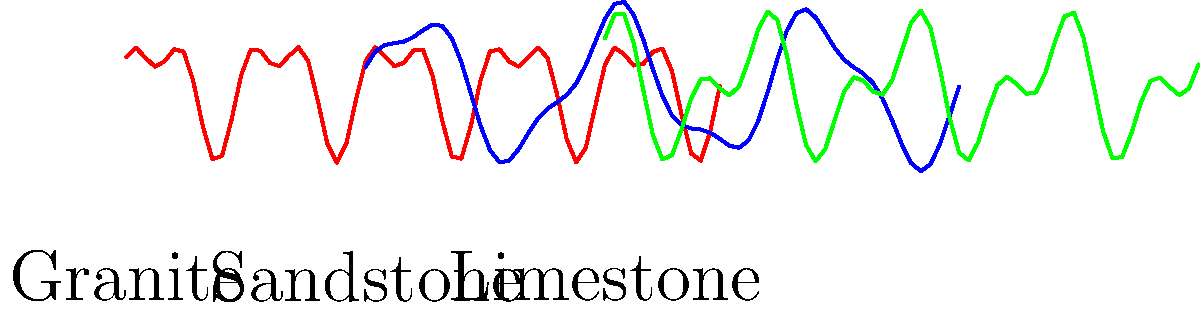Analyze the fractal patterns depicted in the graph for granite, sandstone, and limestone. Which rock type exhibits the highest fractal dimension, indicating the most complex and intricate pattern? To determine which rock type has the highest fractal dimension, we need to analyze the complexity and self-similarity of each pattern:

1. Granite (red curve):
   - Shows a combination of high and low-frequency oscillations
   - Has a relatively complex pattern with multiple peaks and valleys
   - Exhibits some self-similarity at different scales

2. Sandstone (blue curve):
   - Displays a smoother pattern with fewer oscillations
   - Has less complexity compared to granite
   - Shows some self-similarity, but at a larger scale

3. Limestone (green curve):
   - Demonstrates the most complex pattern among the three
   - Combines high-frequency oscillations with larger-scale variations
   - Exhibits strong self-similarity at multiple scales

The fractal dimension is a measure of how a pattern's complexity changes with scale. A higher fractal dimension indicates a more complex and intricate pattern that fills more space.

Based on these observations:
- Limestone shows the most complex pattern with multiple scales of self-similarity
- Granite has the second most complex pattern
- Sandstone has the least complex pattern among the three

Therefore, limestone exhibits the highest fractal dimension, indicating the most complex and intricate pattern among the three rock types.
Answer: Limestone 